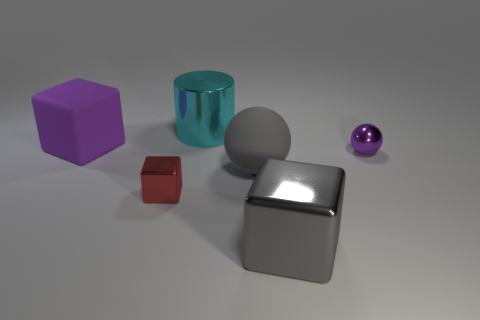There is a tiny shiny block; does it have the same color as the large rubber thing in front of the purple cube?
Your answer should be very brief. No. What shape is the metallic thing that is behind the small red object and in front of the cylinder?
Offer a very short reply. Sphere. What is the material of the large cube that is behind the tiny red shiny thing right of the purple thing left of the cyan metallic thing?
Your answer should be very brief. Rubber. Are there more large matte things that are to the right of the gray matte thing than large gray metallic blocks that are left of the big matte block?
Keep it short and to the point. No. What number of small gray cylinders are made of the same material as the large cylinder?
Your answer should be compact. 0. Is the shape of the tiny object that is behind the tiny red object the same as the small shiny thing in front of the small purple ball?
Keep it short and to the point. No. What is the color of the metal cube that is left of the big ball?
Your response must be concise. Red. Are there any small purple matte things that have the same shape as the big purple object?
Ensure brevity in your answer.  No. What material is the large cyan cylinder?
Offer a very short reply. Metal. What is the size of the block that is on the left side of the big metal cylinder and in front of the gray matte sphere?
Keep it short and to the point. Small. 